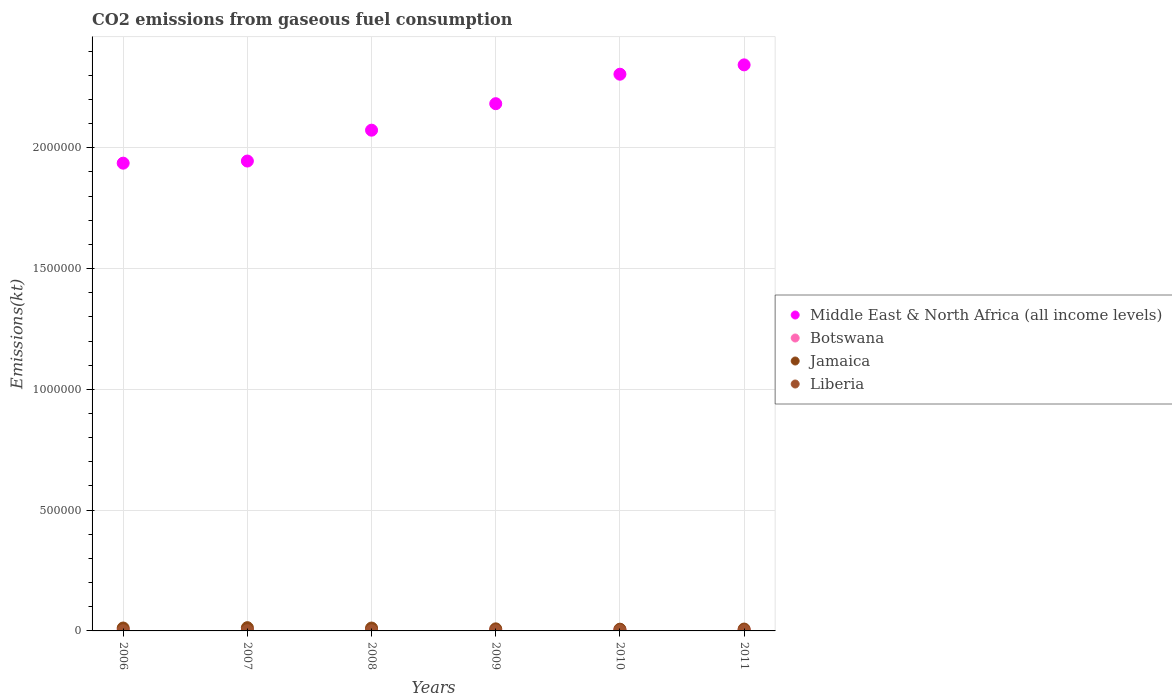How many different coloured dotlines are there?
Your answer should be compact. 4. Is the number of dotlines equal to the number of legend labels?
Your response must be concise. Yes. What is the amount of CO2 emitted in Botswana in 2008?
Offer a terse response. 4979.79. Across all years, what is the maximum amount of CO2 emitted in Middle East & North Africa (all income levels)?
Your answer should be very brief. 2.34e+06. Across all years, what is the minimum amount of CO2 emitted in Middle East & North Africa (all income levels)?
Your response must be concise. 1.94e+06. What is the total amount of CO2 emitted in Jamaica in the graph?
Your answer should be very brief. 6.10e+04. What is the difference between the amount of CO2 emitted in Middle East & North Africa (all income levels) in 2006 and that in 2007?
Your answer should be very brief. -8745.79. What is the difference between the amount of CO2 emitted in Jamaica in 2006 and the amount of CO2 emitted in Middle East & North Africa (all income levels) in 2011?
Keep it short and to the point. -2.33e+06. What is the average amount of CO2 emitted in Liberia per year?
Ensure brevity in your answer.  705.9. In the year 2007, what is the difference between the amount of CO2 emitted in Middle East & North Africa (all income levels) and amount of CO2 emitted in Botswana?
Keep it short and to the point. 1.94e+06. What is the ratio of the amount of CO2 emitted in Botswana in 2006 to that in 2010?
Offer a terse response. 0.89. Is the difference between the amount of CO2 emitted in Middle East & North Africa (all income levels) in 2006 and 2007 greater than the difference between the amount of CO2 emitted in Botswana in 2006 and 2007?
Your answer should be very brief. No. What is the difference between the highest and the second highest amount of CO2 emitted in Jamaica?
Give a very brief answer. 1459.47. What is the difference between the highest and the lowest amount of CO2 emitted in Botswana?
Keep it short and to the point. 832.41. In how many years, is the amount of CO2 emitted in Middle East & North Africa (all income levels) greater than the average amount of CO2 emitted in Middle East & North Africa (all income levels) taken over all years?
Your response must be concise. 3. Is the sum of the amount of CO2 emitted in Middle East & North Africa (all income levels) in 2006 and 2009 greater than the maximum amount of CO2 emitted in Botswana across all years?
Provide a short and direct response. Yes. Is it the case that in every year, the sum of the amount of CO2 emitted in Jamaica and amount of CO2 emitted in Liberia  is greater than the sum of amount of CO2 emitted in Botswana and amount of CO2 emitted in Middle East & North Africa (all income levels)?
Keep it short and to the point. No. Is the amount of CO2 emitted in Middle East & North Africa (all income levels) strictly greater than the amount of CO2 emitted in Liberia over the years?
Your answer should be very brief. Yes. Is the amount of CO2 emitted in Liberia strictly less than the amount of CO2 emitted in Jamaica over the years?
Give a very brief answer. Yes. How many dotlines are there?
Your answer should be very brief. 4. How many years are there in the graph?
Make the answer very short. 6. What is the difference between two consecutive major ticks on the Y-axis?
Give a very brief answer. 5.00e+05. Does the graph contain any zero values?
Make the answer very short. No. Does the graph contain grids?
Your answer should be compact. Yes. What is the title of the graph?
Your answer should be very brief. CO2 emissions from gaseous fuel consumption. What is the label or title of the Y-axis?
Make the answer very short. Emissions(kt). What is the Emissions(kt) in Middle East & North Africa (all income levels) in 2006?
Offer a terse response. 1.94e+06. What is the Emissions(kt) of Botswana in 2006?
Provide a succinct answer. 4646.09. What is the Emissions(kt) in Jamaica in 2006?
Offer a very short reply. 1.20e+04. What is the Emissions(kt) of Liberia in 2006?
Make the answer very short. 759.07. What is the Emissions(kt) of Middle East & North Africa (all income levels) in 2007?
Give a very brief answer. 1.95e+06. What is the Emissions(kt) in Botswana in 2007?
Offer a very short reply. 4701.09. What is the Emissions(kt) of Jamaica in 2007?
Make the answer very short. 1.35e+04. What is the Emissions(kt) of Liberia in 2007?
Provide a short and direct response. 678.39. What is the Emissions(kt) of Middle East & North Africa (all income levels) in 2008?
Keep it short and to the point. 2.07e+06. What is the Emissions(kt) in Botswana in 2008?
Your answer should be very brief. 4979.79. What is the Emissions(kt) of Jamaica in 2008?
Provide a succinct answer. 1.20e+04. What is the Emissions(kt) of Liberia in 2008?
Give a very brief answer. 575.72. What is the Emissions(kt) of Middle East & North Africa (all income levels) in 2009?
Give a very brief answer. 2.18e+06. What is the Emissions(kt) of Botswana in 2009?
Your answer should be compact. 4400.4. What is the Emissions(kt) of Jamaica in 2009?
Provide a short and direct response. 8591.78. What is the Emissions(kt) in Liberia in 2009?
Give a very brief answer. 528.05. What is the Emissions(kt) in Middle East & North Africa (all income levels) in 2010?
Give a very brief answer. 2.30e+06. What is the Emissions(kt) in Botswana in 2010?
Give a very brief answer. 5232.81. What is the Emissions(kt) of Jamaica in 2010?
Make the answer very short. 7190.99. What is the Emissions(kt) of Liberia in 2010?
Offer a terse response. 803.07. What is the Emissions(kt) in Middle East & North Africa (all income levels) in 2011?
Ensure brevity in your answer.  2.34e+06. What is the Emissions(kt) in Botswana in 2011?
Offer a very short reply. 4855.11. What is the Emissions(kt) in Jamaica in 2011?
Provide a short and direct response. 7755.7. What is the Emissions(kt) of Liberia in 2011?
Offer a very short reply. 891.08. Across all years, what is the maximum Emissions(kt) of Middle East & North Africa (all income levels)?
Offer a very short reply. 2.34e+06. Across all years, what is the maximum Emissions(kt) of Botswana?
Make the answer very short. 5232.81. Across all years, what is the maximum Emissions(kt) in Jamaica?
Your answer should be very brief. 1.35e+04. Across all years, what is the maximum Emissions(kt) in Liberia?
Offer a very short reply. 891.08. Across all years, what is the minimum Emissions(kt) of Middle East & North Africa (all income levels)?
Your answer should be very brief. 1.94e+06. Across all years, what is the minimum Emissions(kt) of Botswana?
Offer a very short reply. 4400.4. Across all years, what is the minimum Emissions(kt) in Jamaica?
Give a very brief answer. 7190.99. Across all years, what is the minimum Emissions(kt) in Liberia?
Your response must be concise. 528.05. What is the total Emissions(kt) in Middle East & North Africa (all income levels) in the graph?
Make the answer very short. 1.28e+07. What is the total Emissions(kt) of Botswana in the graph?
Give a very brief answer. 2.88e+04. What is the total Emissions(kt) in Jamaica in the graph?
Your answer should be compact. 6.10e+04. What is the total Emissions(kt) of Liberia in the graph?
Provide a short and direct response. 4235.39. What is the difference between the Emissions(kt) of Middle East & North Africa (all income levels) in 2006 and that in 2007?
Provide a succinct answer. -8745.8. What is the difference between the Emissions(kt) in Botswana in 2006 and that in 2007?
Keep it short and to the point. -55.01. What is the difference between the Emissions(kt) in Jamaica in 2006 and that in 2007?
Your answer should be compact. -1459.47. What is the difference between the Emissions(kt) of Liberia in 2006 and that in 2007?
Offer a very short reply. 80.67. What is the difference between the Emissions(kt) in Middle East & North Africa (all income levels) in 2006 and that in 2008?
Offer a very short reply. -1.37e+05. What is the difference between the Emissions(kt) in Botswana in 2006 and that in 2008?
Make the answer very short. -333.7. What is the difference between the Emissions(kt) in Jamaica in 2006 and that in 2008?
Give a very brief answer. 58.67. What is the difference between the Emissions(kt) in Liberia in 2006 and that in 2008?
Keep it short and to the point. 183.35. What is the difference between the Emissions(kt) of Middle East & North Africa (all income levels) in 2006 and that in 2009?
Provide a succinct answer. -2.46e+05. What is the difference between the Emissions(kt) in Botswana in 2006 and that in 2009?
Give a very brief answer. 245.69. What is the difference between the Emissions(kt) of Jamaica in 2006 and that in 2009?
Your answer should be compact. 3428.64. What is the difference between the Emissions(kt) of Liberia in 2006 and that in 2009?
Ensure brevity in your answer.  231.02. What is the difference between the Emissions(kt) of Middle East & North Africa (all income levels) in 2006 and that in 2010?
Provide a succinct answer. -3.68e+05. What is the difference between the Emissions(kt) in Botswana in 2006 and that in 2010?
Provide a succinct answer. -586.72. What is the difference between the Emissions(kt) in Jamaica in 2006 and that in 2010?
Make the answer very short. 4829.44. What is the difference between the Emissions(kt) of Liberia in 2006 and that in 2010?
Keep it short and to the point. -44. What is the difference between the Emissions(kt) in Middle East & North Africa (all income levels) in 2006 and that in 2011?
Ensure brevity in your answer.  -4.07e+05. What is the difference between the Emissions(kt) in Botswana in 2006 and that in 2011?
Offer a terse response. -209.02. What is the difference between the Emissions(kt) in Jamaica in 2006 and that in 2011?
Your answer should be very brief. 4264.72. What is the difference between the Emissions(kt) of Liberia in 2006 and that in 2011?
Offer a very short reply. -132.01. What is the difference between the Emissions(kt) in Middle East & North Africa (all income levels) in 2007 and that in 2008?
Keep it short and to the point. -1.28e+05. What is the difference between the Emissions(kt) of Botswana in 2007 and that in 2008?
Provide a succinct answer. -278.69. What is the difference between the Emissions(kt) in Jamaica in 2007 and that in 2008?
Provide a short and direct response. 1518.14. What is the difference between the Emissions(kt) of Liberia in 2007 and that in 2008?
Your response must be concise. 102.68. What is the difference between the Emissions(kt) of Middle East & North Africa (all income levels) in 2007 and that in 2009?
Offer a terse response. -2.37e+05. What is the difference between the Emissions(kt) of Botswana in 2007 and that in 2009?
Your answer should be compact. 300.69. What is the difference between the Emissions(kt) in Jamaica in 2007 and that in 2009?
Make the answer very short. 4888.11. What is the difference between the Emissions(kt) in Liberia in 2007 and that in 2009?
Ensure brevity in your answer.  150.35. What is the difference between the Emissions(kt) of Middle East & North Africa (all income levels) in 2007 and that in 2010?
Provide a short and direct response. -3.59e+05. What is the difference between the Emissions(kt) in Botswana in 2007 and that in 2010?
Keep it short and to the point. -531.72. What is the difference between the Emissions(kt) in Jamaica in 2007 and that in 2010?
Offer a terse response. 6288.9. What is the difference between the Emissions(kt) in Liberia in 2007 and that in 2010?
Your answer should be compact. -124.68. What is the difference between the Emissions(kt) in Middle East & North Africa (all income levels) in 2007 and that in 2011?
Offer a very short reply. -3.98e+05. What is the difference between the Emissions(kt) of Botswana in 2007 and that in 2011?
Provide a short and direct response. -154.01. What is the difference between the Emissions(kt) in Jamaica in 2007 and that in 2011?
Provide a succinct answer. 5724.19. What is the difference between the Emissions(kt) in Liberia in 2007 and that in 2011?
Give a very brief answer. -212.69. What is the difference between the Emissions(kt) in Middle East & North Africa (all income levels) in 2008 and that in 2009?
Provide a succinct answer. -1.10e+05. What is the difference between the Emissions(kt) of Botswana in 2008 and that in 2009?
Offer a terse response. 579.39. What is the difference between the Emissions(kt) of Jamaica in 2008 and that in 2009?
Keep it short and to the point. 3369.97. What is the difference between the Emissions(kt) in Liberia in 2008 and that in 2009?
Your answer should be compact. 47.67. What is the difference between the Emissions(kt) in Middle East & North Africa (all income levels) in 2008 and that in 2010?
Make the answer very short. -2.32e+05. What is the difference between the Emissions(kt) of Botswana in 2008 and that in 2010?
Offer a very short reply. -253.02. What is the difference between the Emissions(kt) of Jamaica in 2008 and that in 2010?
Provide a short and direct response. 4770.77. What is the difference between the Emissions(kt) of Liberia in 2008 and that in 2010?
Keep it short and to the point. -227.35. What is the difference between the Emissions(kt) in Middle East & North Africa (all income levels) in 2008 and that in 2011?
Offer a terse response. -2.70e+05. What is the difference between the Emissions(kt) in Botswana in 2008 and that in 2011?
Keep it short and to the point. 124.68. What is the difference between the Emissions(kt) in Jamaica in 2008 and that in 2011?
Provide a short and direct response. 4206.05. What is the difference between the Emissions(kt) in Liberia in 2008 and that in 2011?
Make the answer very short. -315.36. What is the difference between the Emissions(kt) in Middle East & North Africa (all income levels) in 2009 and that in 2010?
Provide a succinct answer. -1.22e+05. What is the difference between the Emissions(kt) of Botswana in 2009 and that in 2010?
Your answer should be compact. -832.41. What is the difference between the Emissions(kt) in Jamaica in 2009 and that in 2010?
Offer a terse response. 1400.79. What is the difference between the Emissions(kt) of Liberia in 2009 and that in 2010?
Give a very brief answer. -275.02. What is the difference between the Emissions(kt) of Middle East & North Africa (all income levels) in 2009 and that in 2011?
Provide a short and direct response. -1.61e+05. What is the difference between the Emissions(kt) in Botswana in 2009 and that in 2011?
Provide a succinct answer. -454.71. What is the difference between the Emissions(kt) in Jamaica in 2009 and that in 2011?
Make the answer very short. 836.08. What is the difference between the Emissions(kt) in Liberia in 2009 and that in 2011?
Keep it short and to the point. -363.03. What is the difference between the Emissions(kt) in Middle East & North Africa (all income levels) in 2010 and that in 2011?
Make the answer very short. -3.87e+04. What is the difference between the Emissions(kt) in Botswana in 2010 and that in 2011?
Your response must be concise. 377.7. What is the difference between the Emissions(kt) in Jamaica in 2010 and that in 2011?
Provide a succinct answer. -564.72. What is the difference between the Emissions(kt) in Liberia in 2010 and that in 2011?
Offer a very short reply. -88.01. What is the difference between the Emissions(kt) in Middle East & North Africa (all income levels) in 2006 and the Emissions(kt) in Botswana in 2007?
Make the answer very short. 1.93e+06. What is the difference between the Emissions(kt) in Middle East & North Africa (all income levels) in 2006 and the Emissions(kt) in Jamaica in 2007?
Offer a very short reply. 1.92e+06. What is the difference between the Emissions(kt) of Middle East & North Africa (all income levels) in 2006 and the Emissions(kt) of Liberia in 2007?
Offer a terse response. 1.94e+06. What is the difference between the Emissions(kt) in Botswana in 2006 and the Emissions(kt) in Jamaica in 2007?
Your answer should be compact. -8833.8. What is the difference between the Emissions(kt) in Botswana in 2006 and the Emissions(kt) in Liberia in 2007?
Provide a succinct answer. 3967.69. What is the difference between the Emissions(kt) of Jamaica in 2006 and the Emissions(kt) of Liberia in 2007?
Provide a short and direct response. 1.13e+04. What is the difference between the Emissions(kt) of Middle East & North Africa (all income levels) in 2006 and the Emissions(kt) of Botswana in 2008?
Your answer should be very brief. 1.93e+06. What is the difference between the Emissions(kt) of Middle East & North Africa (all income levels) in 2006 and the Emissions(kt) of Jamaica in 2008?
Offer a terse response. 1.92e+06. What is the difference between the Emissions(kt) of Middle East & North Africa (all income levels) in 2006 and the Emissions(kt) of Liberia in 2008?
Provide a succinct answer. 1.94e+06. What is the difference between the Emissions(kt) of Botswana in 2006 and the Emissions(kt) of Jamaica in 2008?
Keep it short and to the point. -7315.66. What is the difference between the Emissions(kt) in Botswana in 2006 and the Emissions(kt) in Liberia in 2008?
Make the answer very short. 4070.37. What is the difference between the Emissions(kt) in Jamaica in 2006 and the Emissions(kt) in Liberia in 2008?
Provide a short and direct response. 1.14e+04. What is the difference between the Emissions(kt) of Middle East & North Africa (all income levels) in 2006 and the Emissions(kt) of Botswana in 2009?
Your answer should be compact. 1.93e+06. What is the difference between the Emissions(kt) in Middle East & North Africa (all income levels) in 2006 and the Emissions(kt) in Jamaica in 2009?
Keep it short and to the point. 1.93e+06. What is the difference between the Emissions(kt) of Middle East & North Africa (all income levels) in 2006 and the Emissions(kt) of Liberia in 2009?
Your answer should be compact. 1.94e+06. What is the difference between the Emissions(kt) in Botswana in 2006 and the Emissions(kt) in Jamaica in 2009?
Offer a terse response. -3945.69. What is the difference between the Emissions(kt) in Botswana in 2006 and the Emissions(kt) in Liberia in 2009?
Your response must be concise. 4118.04. What is the difference between the Emissions(kt) of Jamaica in 2006 and the Emissions(kt) of Liberia in 2009?
Your answer should be very brief. 1.15e+04. What is the difference between the Emissions(kt) of Middle East & North Africa (all income levels) in 2006 and the Emissions(kt) of Botswana in 2010?
Provide a short and direct response. 1.93e+06. What is the difference between the Emissions(kt) of Middle East & North Africa (all income levels) in 2006 and the Emissions(kt) of Jamaica in 2010?
Make the answer very short. 1.93e+06. What is the difference between the Emissions(kt) in Middle East & North Africa (all income levels) in 2006 and the Emissions(kt) in Liberia in 2010?
Your answer should be compact. 1.94e+06. What is the difference between the Emissions(kt) in Botswana in 2006 and the Emissions(kt) in Jamaica in 2010?
Give a very brief answer. -2544.9. What is the difference between the Emissions(kt) of Botswana in 2006 and the Emissions(kt) of Liberia in 2010?
Your answer should be compact. 3843.02. What is the difference between the Emissions(kt) in Jamaica in 2006 and the Emissions(kt) in Liberia in 2010?
Provide a succinct answer. 1.12e+04. What is the difference between the Emissions(kt) in Middle East & North Africa (all income levels) in 2006 and the Emissions(kt) in Botswana in 2011?
Give a very brief answer. 1.93e+06. What is the difference between the Emissions(kt) of Middle East & North Africa (all income levels) in 2006 and the Emissions(kt) of Jamaica in 2011?
Offer a terse response. 1.93e+06. What is the difference between the Emissions(kt) in Middle East & North Africa (all income levels) in 2006 and the Emissions(kt) in Liberia in 2011?
Offer a very short reply. 1.94e+06. What is the difference between the Emissions(kt) in Botswana in 2006 and the Emissions(kt) in Jamaica in 2011?
Offer a terse response. -3109.62. What is the difference between the Emissions(kt) in Botswana in 2006 and the Emissions(kt) in Liberia in 2011?
Your response must be concise. 3755.01. What is the difference between the Emissions(kt) in Jamaica in 2006 and the Emissions(kt) in Liberia in 2011?
Your answer should be very brief. 1.11e+04. What is the difference between the Emissions(kt) in Middle East & North Africa (all income levels) in 2007 and the Emissions(kt) in Botswana in 2008?
Ensure brevity in your answer.  1.94e+06. What is the difference between the Emissions(kt) of Middle East & North Africa (all income levels) in 2007 and the Emissions(kt) of Jamaica in 2008?
Ensure brevity in your answer.  1.93e+06. What is the difference between the Emissions(kt) of Middle East & North Africa (all income levels) in 2007 and the Emissions(kt) of Liberia in 2008?
Your answer should be compact. 1.94e+06. What is the difference between the Emissions(kt) of Botswana in 2007 and the Emissions(kt) of Jamaica in 2008?
Provide a succinct answer. -7260.66. What is the difference between the Emissions(kt) in Botswana in 2007 and the Emissions(kt) in Liberia in 2008?
Keep it short and to the point. 4125.38. What is the difference between the Emissions(kt) in Jamaica in 2007 and the Emissions(kt) in Liberia in 2008?
Keep it short and to the point. 1.29e+04. What is the difference between the Emissions(kt) of Middle East & North Africa (all income levels) in 2007 and the Emissions(kt) of Botswana in 2009?
Your answer should be very brief. 1.94e+06. What is the difference between the Emissions(kt) in Middle East & North Africa (all income levels) in 2007 and the Emissions(kt) in Jamaica in 2009?
Provide a succinct answer. 1.94e+06. What is the difference between the Emissions(kt) in Middle East & North Africa (all income levels) in 2007 and the Emissions(kt) in Liberia in 2009?
Ensure brevity in your answer.  1.94e+06. What is the difference between the Emissions(kt) of Botswana in 2007 and the Emissions(kt) of Jamaica in 2009?
Your response must be concise. -3890.69. What is the difference between the Emissions(kt) of Botswana in 2007 and the Emissions(kt) of Liberia in 2009?
Your answer should be compact. 4173.05. What is the difference between the Emissions(kt) in Jamaica in 2007 and the Emissions(kt) in Liberia in 2009?
Ensure brevity in your answer.  1.30e+04. What is the difference between the Emissions(kt) in Middle East & North Africa (all income levels) in 2007 and the Emissions(kt) in Botswana in 2010?
Provide a short and direct response. 1.94e+06. What is the difference between the Emissions(kt) in Middle East & North Africa (all income levels) in 2007 and the Emissions(kt) in Jamaica in 2010?
Ensure brevity in your answer.  1.94e+06. What is the difference between the Emissions(kt) of Middle East & North Africa (all income levels) in 2007 and the Emissions(kt) of Liberia in 2010?
Your answer should be very brief. 1.94e+06. What is the difference between the Emissions(kt) in Botswana in 2007 and the Emissions(kt) in Jamaica in 2010?
Keep it short and to the point. -2489.89. What is the difference between the Emissions(kt) in Botswana in 2007 and the Emissions(kt) in Liberia in 2010?
Make the answer very short. 3898.02. What is the difference between the Emissions(kt) in Jamaica in 2007 and the Emissions(kt) in Liberia in 2010?
Provide a succinct answer. 1.27e+04. What is the difference between the Emissions(kt) of Middle East & North Africa (all income levels) in 2007 and the Emissions(kt) of Botswana in 2011?
Give a very brief answer. 1.94e+06. What is the difference between the Emissions(kt) in Middle East & North Africa (all income levels) in 2007 and the Emissions(kt) in Jamaica in 2011?
Provide a short and direct response. 1.94e+06. What is the difference between the Emissions(kt) in Middle East & North Africa (all income levels) in 2007 and the Emissions(kt) in Liberia in 2011?
Offer a very short reply. 1.94e+06. What is the difference between the Emissions(kt) of Botswana in 2007 and the Emissions(kt) of Jamaica in 2011?
Your answer should be very brief. -3054.61. What is the difference between the Emissions(kt) of Botswana in 2007 and the Emissions(kt) of Liberia in 2011?
Your response must be concise. 3810.01. What is the difference between the Emissions(kt) of Jamaica in 2007 and the Emissions(kt) of Liberia in 2011?
Ensure brevity in your answer.  1.26e+04. What is the difference between the Emissions(kt) in Middle East & North Africa (all income levels) in 2008 and the Emissions(kt) in Botswana in 2009?
Keep it short and to the point. 2.07e+06. What is the difference between the Emissions(kt) in Middle East & North Africa (all income levels) in 2008 and the Emissions(kt) in Jamaica in 2009?
Provide a succinct answer. 2.06e+06. What is the difference between the Emissions(kt) in Middle East & North Africa (all income levels) in 2008 and the Emissions(kt) in Liberia in 2009?
Give a very brief answer. 2.07e+06. What is the difference between the Emissions(kt) of Botswana in 2008 and the Emissions(kt) of Jamaica in 2009?
Give a very brief answer. -3611.99. What is the difference between the Emissions(kt) of Botswana in 2008 and the Emissions(kt) of Liberia in 2009?
Your answer should be very brief. 4451.74. What is the difference between the Emissions(kt) in Jamaica in 2008 and the Emissions(kt) in Liberia in 2009?
Offer a terse response. 1.14e+04. What is the difference between the Emissions(kt) in Middle East & North Africa (all income levels) in 2008 and the Emissions(kt) in Botswana in 2010?
Give a very brief answer. 2.07e+06. What is the difference between the Emissions(kt) of Middle East & North Africa (all income levels) in 2008 and the Emissions(kt) of Jamaica in 2010?
Provide a short and direct response. 2.07e+06. What is the difference between the Emissions(kt) in Middle East & North Africa (all income levels) in 2008 and the Emissions(kt) in Liberia in 2010?
Provide a succinct answer. 2.07e+06. What is the difference between the Emissions(kt) in Botswana in 2008 and the Emissions(kt) in Jamaica in 2010?
Give a very brief answer. -2211.2. What is the difference between the Emissions(kt) in Botswana in 2008 and the Emissions(kt) in Liberia in 2010?
Provide a succinct answer. 4176.71. What is the difference between the Emissions(kt) in Jamaica in 2008 and the Emissions(kt) in Liberia in 2010?
Provide a short and direct response. 1.12e+04. What is the difference between the Emissions(kt) of Middle East & North Africa (all income levels) in 2008 and the Emissions(kt) of Botswana in 2011?
Provide a succinct answer. 2.07e+06. What is the difference between the Emissions(kt) of Middle East & North Africa (all income levels) in 2008 and the Emissions(kt) of Jamaica in 2011?
Make the answer very short. 2.07e+06. What is the difference between the Emissions(kt) in Middle East & North Africa (all income levels) in 2008 and the Emissions(kt) in Liberia in 2011?
Ensure brevity in your answer.  2.07e+06. What is the difference between the Emissions(kt) in Botswana in 2008 and the Emissions(kt) in Jamaica in 2011?
Your response must be concise. -2775.92. What is the difference between the Emissions(kt) of Botswana in 2008 and the Emissions(kt) of Liberia in 2011?
Offer a very short reply. 4088.7. What is the difference between the Emissions(kt) of Jamaica in 2008 and the Emissions(kt) of Liberia in 2011?
Give a very brief answer. 1.11e+04. What is the difference between the Emissions(kt) in Middle East & North Africa (all income levels) in 2009 and the Emissions(kt) in Botswana in 2010?
Keep it short and to the point. 2.18e+06. What is the difference between the Emissions(kt) of Middle East & North Africa (all income levels) in 2009 and the Emissions(kt) of Jamaica in 2010?
Provide a short and direct response. 2.18e+06. What is the difference between the Emissions(kt) in Middle East & North Africa (all income levels) in 2009 and the Emissions(kt) in Liberia in 2010?
Your answer should be very brief. 2.18e+06. What is the difference between the Emissions(kt) of Botswana in 2009 and the Emissions(kt) of Jamaica in 2010?
Provide a succinct answer. -2790.59. What is the difference between the Emissions(kt) in Botswana in 2009 and the Emissions(kt) in Liberia in 2010?
Ensure brevity in your answer.  3597.33. What is the difference between the Emissions(kt) in Jamaica in 2009 and the Emissions(kt) in Liberia in 2010?
Your response must be concise. 7788.71. What is the difference between the Emissions(kt) of Middle East & North Africa (all income levels) in 2009 and the Emissions(kt) of Botswana in 2011?
Your answer should be compact. 2.18e+06. What is the difference between the Emissions(kt) in Middle East & North Africa (all income levels) in 2009 and the Emissions(kt) in Jamaica in 2011?
Provide a short and direct response. 2.17e+06. What is the difference between the Emissions(kt) in Middle East & North Africa (all income levels) in 2009 and the Emissions(kt) in Liberia in 2011?
Your answer should be compact. 2.18e+06. What is the difference between the Emissions(kt) of Botswana in 2009 and the Emissions(kt) of Jamaica in 2011?
Ensure brevity in your answer.  -3355.3. What is the difference between the Emissions(kt) of Botswana in 2009 and the Emissions(kt) of Liberia in 2011?
Keep it short and to the point. 3509.32. What is the difference between the Emissions(kt) in Jamaica in 2009 and the Emissions(kt) in Liberia in 2011?
Give a very brief answer. 7700.7. What is the difference between the Emissions(kt) in Middle East & North Africa (all income levels) in 2010 and the Emissions(kt) in Botswana in 2011?
Make the answer very short. 2.30e+06. What is the difference between the Emissions(kt) in Middle East & North Africa (all income levels) in 2010 and the Emissions(kt) in Jamaica in 2011?
Your response must be concise. 2.30e+06. What is the difference between the Emissions(kt) in Middle East & North Africa (all income levels) in 2010 and the Emissions(kt) in Liberia in 2011?
Offer a very short reply. 2.30e+06. What is the difference between the Emissions(kt) in Botswana in 2010 and the Emissions(kt) in Jamaica in 2011?
Provide a short and direct response. -2522.9. What is the difference between the Emissions(kt) in Botswana in 2010 and the Emissions(kt) in Liberia in 2011?
Keep it short and to the point. 4341.73. What is the difference between the Emissions(kt) in Jamaica in 2010 and the Emissions(kt) in Liberia in 2011?
Provide a short and direct response. 6299.91. What is the average Emissions(kt) in Middle East & North Africa (all income levels) per year?
Offer a terse response. 2.13e+06. What is the average Emissions(kt) in Botswana per year?
Offer a terse response. 4802.55. What is the average Emissions(kt) of Jamaica per year?
Your response must be concise. 1.02e+04. What is the average Emissions(kt) in Liberia per year?
Ensure brevity in your answer.  705.9. In the year 2006, what is the difference between the Emissions(kt) in Middle East & North Africa (all income levels) and Emissions(kt) in Botswana?
Keep it short and to the point. 1.93e+06. In the year 2006, what is the difference between the Emissions(kt) in Middle East & North Africa (all income levels) and Emissions(kt) in Jamaica?
Offer a terse response. 1.92e+06. In the year 2006, what is the difference between the Emissions(kt) in Middle East & North Africa (all income levels) and Emissions(kt) in Liberia?
Provide a short and direct response. 1.94e+06. In the year 2006, what is the difference between the Emissions(kt) of Botswana and Emissions(kt) of Jamaica?
Offer a terse response. -7374.34. In the year 2006, what is the difference between the Emissions(kt) of Botswana and Emissions(kt) of Liberia?
Offer a terse response. 3887.02. In the year 2006, what is the difference between the Emissions(kt) of Jamaica and Emissions(kt) of Liberia?
Provide a succinct answer. 1.13e+04. In the year 2007, what is the difference between the Emissions(kt) of Middle East & North Africa (all income levels) and Emissions(kt) of Botswana?
Your answer should be compact. 1.94e+06. In the year 2007, what is the difference between the Emissions(kt) of Middle East & North Africa (all income levels) and Emissions(kt) of Jamaica?
Keep it short and to the point. 1.93e+06. In the year 2007, what is the difference between the Emissions(kt) of Middle East & North Africa (all income levels) and Emissions(kt) of Liberia?
Offer a terse response. 1.94e+06. In the year 2007, what is the difference between the Emissions(kt) in Botswana and Emissions(kt) in Jamaica?
Make the answer very short. -8778.8. In the year 2007, what is the difference between the Emissions(kt) of Botswana and Emissions(kt) of Liberia?
Give a very brief answer. 4022.7. In the year 2007, what is the difference between the Emissions(kt) in Jamaica and Emissions(kt) in Liberia?
Offer a terse response. 1.28e+04. In the year 2008, what is the difference between the Emissions(kt) of Middle East & North Africa (all income levels) and Emissions(kt) of Botswana?
Offer a terse response. 2.07e+06. In the year 2008, what is the difference between the Emissions(kt) of Middle East & North Africa (all income levels) and Emissions(kt) of Jamaica?
Offer a very short reply. 2.06e+06. In the year 2008, what is the difference between the Emissions(kt) of Middle East & North Africa (all income levels) and Emissions(kt) of Liberia?
Provide a succinct answer. 2.07e+06. In the year 2008, what is the difference between the Emissions(kt) in Botswana and Emissions(kt) in Jamaica?
Provide a short and direct response. -6981.97. In the year 2008, what is the difference between the Emissions(kt) of Botswana and Emissions(kt) of Liberia?
Provide a short and direct response. 4404.07. In the year 2008, what is the difference between the Emissions(kt) of Jamaica and Emissions(kt) of Liberia?
Your response must be concise. 1.14e+04. In the year 2009, what is the difference between the Emissions(kt) of Middle East & North Africa (all income levels) and Emissions(kt) of Botswana?
Offer a very short reply. 2.18e+06. In the year 2009, what is the difference between the Emissions(kt) in Middle East & North Africa (all income levels) and Emissions(kt) in Jamaica?
Provide a short and direct response. 2.17e+06. In the year 2009, what is the difference between the Emissions(kt) of Middle East & North Africa (all income levels) and Emissions(kt) of Liberia?
Make the answer very short. 2.18e+06. In the year 2009, what is the difference between the Emissions(kt) in Botswana and Emissions(kt) in Jamaica?
Keep it short and to the point. -4191.38. In the year 2009, what is the difference between the Emissions(kt) in Botswana and Emissions(kt) in Liberia?
Your answer should be very brief. 3872.35. In the year 2009, what is the difference between the Emissions(kt) in Jamaica and Emissions(kt) in Liberia?
Give a very brief answer. 8063.73. In the year 2010, what is the difference between the Emissions(kt) of Middle East & North Africa (all income levels) and Emissions(kt) of Botswana?
Your answer should be compact. 2.30e+06. In the year 2010, what is the difference between the Emissions(kt) in Middle East & North Africa (all income levels) and Emissions(kt) in Jamaica?
Make the answer very short. 2.30e+06. In the year 2010, what is the difference between the Emissions(kt) in Middle East & North Africa (all income levels) and Emissions(kt) in Liberia?
Ensure brevity in your answer.  2.30e+06. In the year 2010, what is the difference between the Emissions(kt) of Botswana and Emissions(kt) of Jamaica?
Make the answer very short. -1958.18. In the year 2010, what is the difference between the Emissions(kt) in Botswana and Emissions(kt) in Liberia?
Offer a terse response. 4429.74. In the year 2010, what is the difference between the Emissions(kt) of Jamaica and Emissions(kt) of Liberia?
Offer a terse response. 6387.91. In the year 2011, what is the difference between the Emissions(kt) in Middle East & North Africa (all income levels) and Emissions(kt) in Botswana?
Your answer should be compact. 2.34e+06. In the year 2011, what is the difference between the Emissions(kt) of Middle East & North Africa (all income levels) and Emissions(kt) of Jamaica?
Ensure brevity in your answer.  2.34e+06. In the year 2011, what is the difference between the Emissions(kt) of Middle East & North Africa (all income levels) and Emissions(kt) of Liberia?
Offer a terse response. 2.34e+06. In the year 2011, what is the difference between the Emissions(kt) in Botswana and Emissions(kt) in Jamaica?
Offer a terse response. -2900.6. In the year 2011, what is the difference between the Emissions(kt) of Botswana and Emissions(kt) of Liberia?
Offer a very short reply. 3964.03. In the year 2011, what is the difference between the Emissions(kt) in Jamaica and Emissions(kt) in Liberia?
Provide a short and direct response. 6864.62. What is the ratio of the Emissions(kt) of Middle East & North Africa (all income levels) in 2006 to that in 2007?
Offer a very short reply. 1. What is the ratio of the Emissions(kt) of Botswana in 2006 to that in 2007?
Provide a short and direct response. 0.99. What is the ratio of the Emissions(kt) in Jamaica in 2006 to that in 2007?
Offer a terse response. 0.89. What is the ratio of the Emissions(kt) of Liberia in 2006 to that in 2007?
Your response must be concise. 1.12. What is the ratio of the Emissions(kt) of Middle East & North Africa (all income levels) in 2006 to that in 2008?
Provide a short and direct response. 0.93. What is the ratio of the Emissions(kt) of Botswana in 2006 to that in 2008?
Your answer should be very brief. 0.93. What is the ratio of the Emissions(kt) in Liberia in 2006 to that in 2008?
Provide a short and direct response. 1.32. What is the ratio of the Emissions(kt) of Middle East & North Africa (all income levels) in 2006 to that in 2009?
Give a very brief answer. 0.89. What is the ratio of the Emissions(kt) in Botswana in 2006 to that in 2009?
Ensure brevity in your answer.  1.06. What is the ratio of the Emissions(kt) of Jamaica in 2006 to that in 2009?
Give a very brief answer. 1.4. What is the ratio of the Emissions(kt) in Liberia in 2006 to that in 2009?
Make the answer very short. 1.44. What is the ratio of the Emissions(kt) of Middle East & North Africa (all income levels) in 2006 to that in 2010?
Offer a terse response. 0.84. What is the ratio of the Emissions(kt) of Botswana in 2006 to that in 2010?
Provide a short and direct response. 0.89. What is the ratio of the Emissions(kt) of Jamaica in 2006 to that in 2010?
Provide a short and direct response. 1.67. What is the ratio of the Emissions(kt) of Liberia in 2006 to that in 2010?
Offer a terse response. 0.95. What is the ratio of the Emissions(kt) in Middle East & North Africa (all income levels) in 2006 to that in 2011?
Make the answer very short. 0.83. What is the ratio of the Emissions(kt) of Botswana in 2006 to that in 2011?
Give a very brief answer. 0.96. What is the ratio of the Emissions(kt) of Jamaica in 2006 to that in 2011?
Provide a succinct answer. 1.55. What is the ratio of the Emissions(kt) in Liberia in 2006 to that in 2011?
Ensure brevity in your answer.  0.85. What is the ratio of the Emissions(kt) in Middle East & North Africa (all income levels) in 2007 to that in 2008?
Your response must be concise. 0.94. What is the ratio of the Emissions(kt) of Botswana in 2007 to that in 2008?
Your answer should be very brief. 0.94. What is the ratio of the Emissions(kt) of Jamaica in 2007 to that in 2008?
Your response must be concise. 1.13. What is the ratio of the Emissions(kt) of Liberia in 2007 to that in 2008?
Offer a very short reply. 1.18. What is the ratio of the Emissions(kt) in Middle East & North Africa (all income levels) in 2007 to that in 2009?
Offer a terse response. 0.89. What is the ratio of the Emissions(kt) in Botswana in 2007 to that in 2009?
Ensure brevity in your answer.  1.07. What is the ratio of the Emissions(kt) of Jamaica in 2007 to that in 2009?
Make the answer very short. 1.57. What is the ratio of the Emissions(kt) in Liberia in 2007 to that in 2009?
Offer a terse response. 1.28. What is the ratio of the Emissions(kt) in Middle East & North Africa (all income levels) in 2007 to that in 2010?
Provide a short and direct response. 0.84. What is the ratio of the Emissions(kt) in Botswana in 2007 to that in 2010?
Provide a short and direct response. 0.9. What is the ratio of the Emissions(kt) in Jamaica in 2007 to that in 2010?
Offer a very short reply. 1.87. What is the ratio of the Emissions(kt) of Liberia in 2007 to that in 2010?
Ensure brevity in your answer.  0.84. What is the ratio of the Emissions(kt) of Middle East & North Africa (all income levels) in 2007 to that in 2011?
Your answer should be very brief. 0.83. What is the ratio of the Emissions(kt) in Botswana in 2007 to that in 2011?
Your answer should be very brief. 0.97. What is the ratio of the Emissions(kt) in Jamaica in 2007 to that in 2011?
Make the answer very short. 1.74. What is the ratio of the Emissions(kt) in Liberia in 2007 to that in 2011?
Your response must be concise. 0.76. What is the ratio of the Emissions(kt) of Middle East & North Africa (all income levels) in 2008 to that in 2009?
Your answer should be compact. 0.95. What is the ratio of the Emissions(kt) in Botswana in 2008 to that in 2009?
Ensure brevity in your answer.  1.13. What is the ratio of the Emissions(kt) in Jamaica in 2008 to that in 2009?
Your response must be concise. 1.39. What is the ratio of the Emissions(kt) in Liberia in 2008 to that in 2009?
Your response must be concise. 1.09. What is the ratio of the Emissions(kt) in Middle East & North Africa (all income levels) in 2008 to that in 2010?
Keep it short and to the point. 0.9. What is the ratio of the Emissions(kt) in Botswana in 2008 to that in 2010?
Make the answer very short. 0.95. What is the ratio of the Emissions(kt) of Jamaica in 2008 to that in 2010?
Ensure brevity in your answer.  1.66. What is the ratio of the Emissions(kt) of Liberia in 2008 to that in 2010?
Provide a short and direct response. 0.72. What is the ratio of the Emissions(kt) in Middle East & North Africa (all income levels) in 2008 to that in 2011?
Give a very brief answer. 0.88. What is the ratio of the Emissions(kt) in Botswana in 2008 to that in 2011?
Keep it short and to the point. 1.03. What is the ratio of the Emissions(kt) in Jamaica in 2008 to that in 2011?
Give a very brief answer. 1.54. What is the ratio of the Emissions(kt) of Liberia in 2008 to that in 2011?
Provide a short and direct response. 0.65. What is the ratio of the Emissions(kt) of Middle East & North Africa (all income levels) in 2009 to that in 2010?
Make the answer very short. 0.95. What is the ratio of the Emissions(kt) in Botswana in 2009 to that in 2010?
Provide a short and direct response. 0.84. What is the ratio of the Emissions(kt) in Jamaica in 2009 to that in 2010?
Provide a short and direct response. 1.19. What is the ratio of the Emissions(kt) of Liberia in 2009 to that in 2010?
Provide a succinct answer. 0.66. What is the ratio of the Emissions(kt) of Middle East & North Africa (all income levels) in 2009 to that in 2011?
Your response must be concise. 0.93. What is the ratio of the Emissions(kt) in Botswana in 2009 to that in 2011?
Ensure brevity in your answer.  0.91. What is the ratio of the Emissions(kt) in Jamaica in 2009 to that in 2011?
Your answer should be compact. 1.11. What is the ratio of the Emissions(kt) of Liberia in 2009 to that in 2011?
Offer a very short reply. 0.59. What is the ratio of the Emissions(kt) in Middle East & North Africa (all income levels) in 2010 to that in 2011?
Your answer should be compact. 0.98. What is the ratio of the Emissions(kt) of Botswana in 2010 to that in 2011?
Offer a very short reply. 1.08. What is the ratio of the Emissions(kt) of Jamaica in 2010 to that in 2011?
Provide a short and direct response. 0.93. What is the ratio of the Emissions(kt) of Liberia in 2010 to that in 2011?
Provide a succinct answer. 0.9. What is the difference between the highest and the second highest Emissions(kt) of Middle East & North Africa (all income levels)?
Give a very brief answer. 3.87e+04. What is the difference between the highest and the second highest Emissions(kt) of Botswana?
Your answer should be compact. 253.02. What is the difference between the highest and the second highest Emissions(kt) of Jamaica?
Offer a very short reply. 1459.47. What is the difference between the highest and the second highest Emissions(kt) in Liberia?
Give a very brief answer. 88.01. What is the difference between the highest and the lowest Emissions(kt) in Middle East & North Africa (all income levels)?
Your answer should be very brief. 4.07e+05. What is the difference between the highest and the lowest Emissions(kt) of Botswana?
Make the answer very short. 832.41. What is the difference between the highest and the lowest Emissions(kt) of Jamaica?
Keep it short and to the point. 6288.9. What is the difference between the highest and the lowest Emissions(kt) in Liberia?
Make the answer very short. 363.03. 